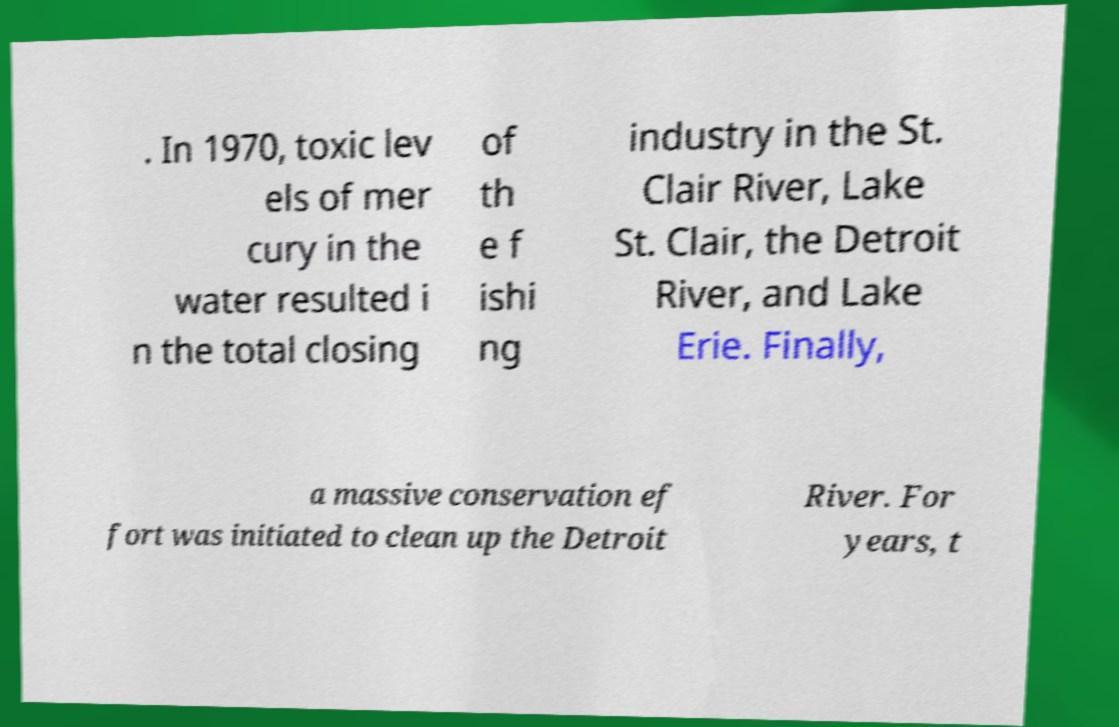Please identify and transcribe the text found in this image. . In 1970, toxic lev els of mer cury in the water resulted i n the total closing of th e f ishi ng industry in the St. Clair River, Lake St. Clair, the Detroit River, and Lake Erie. Finally, a massive conservation ef fort was initiated to clean up the Detroit River. For years, t 